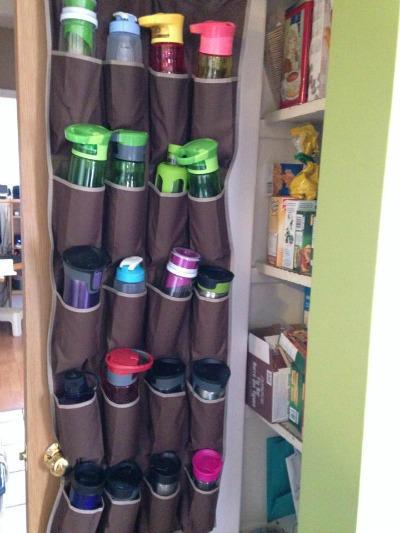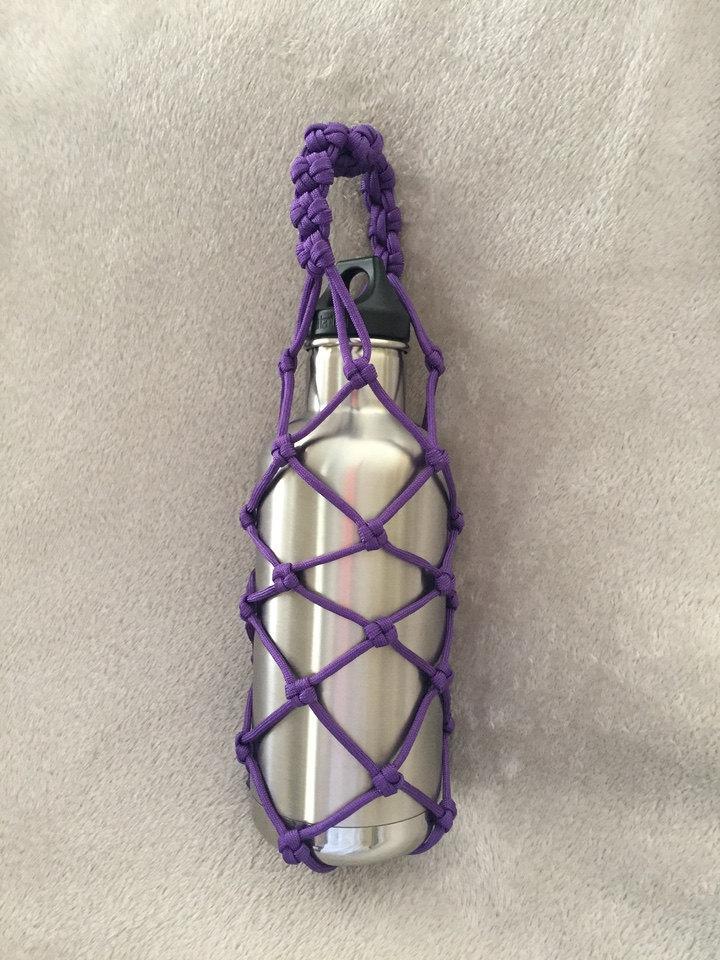The first image is the image on the left, the second image is the image on the right. Considering the images on both sides, is "There is at least one disposable water bottle with a white cap." valid? Answer yes or no. No. The first image is the image on the left, the second image is the image on the right. Given the left and right images, does the statement "singular water bottles are surrounded by rop" hold true? Answer yes or no. Yes. 